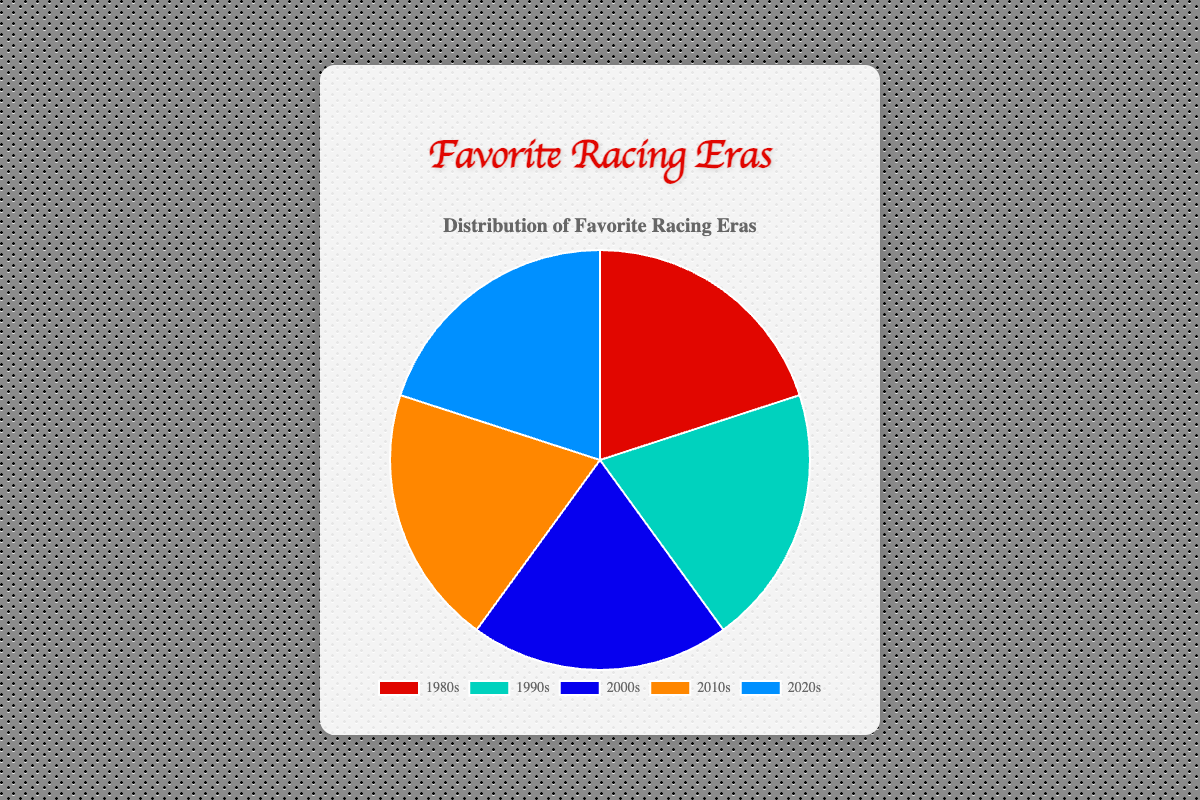Which racing era has the highest number of favorite drivers? The pie chart shows different sections representing the number of favorite drivers in each era. The largest section belongs to the 2010s era.
Answer: 2010s Which era has fewer favorite drivers, the 1980s or the 2020s? By comparing the sizes of the chart sections, the 2020s section is slightly larger than the 1980s, indicating fewer favorite drivers in the 1980s.
Answer: 1980s What is the combined total of favorite drivers for the 1990s and 2000s eras? Both pie sections for the 1990s and 2000s have three drivers each. Therefore, the total is 3 + 3 = 6.
Answer: 6 Which era has more favorite drivers: 1980s or 2000s? The pie section for the 2000s is noticeably larger than the section for the 1980s.
Answer: 2000s Are there equal numbers of favorite drivers in any two eras? Checking the pie sections, both the 1990s and 2000s sections represent three drivers each.
Answer: Yes, 1990s and 2000s Which racing era is represented by the red section of the pie chart? The red section on the pie chart corresponds to one era. According to the color scheme: 1980s.
Answer: 1980s How many more favorite drivers are in the 2010s compared to the 2020s? The 2010s have three favorite drivers, while the 2020s have three. The difference is 3 - 3 = 0.
Answer: 0 Which era is represented by the smallest section of the pie chart? Observing the pie chart, the smallest section represents the 1980s.
Answer: 1980s How does the number of favorite drivers in the 2010s compare to those in the 1990s? Both the 2010s and 1990s pie sections indicate three favorite drivers each. They are equal.
Answer: Equal 